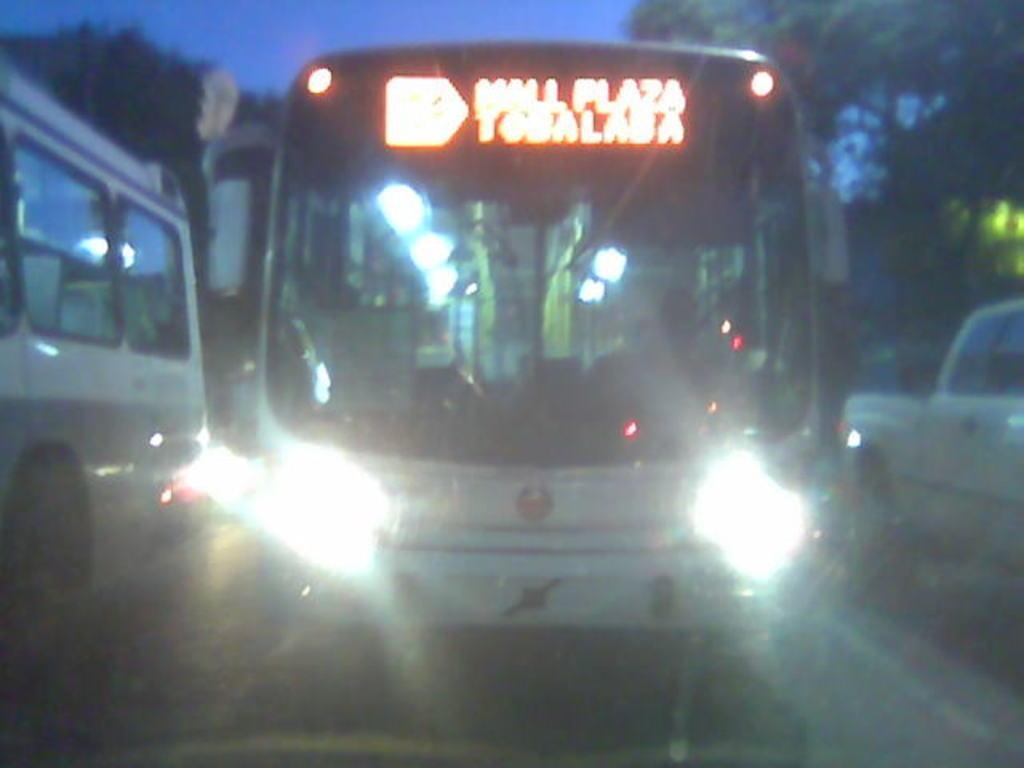In one or two sentences, can you explain what this image depicts? In this image I can see a bus in the center of the image. This is a blurred image I can see other vehicles on the road. 